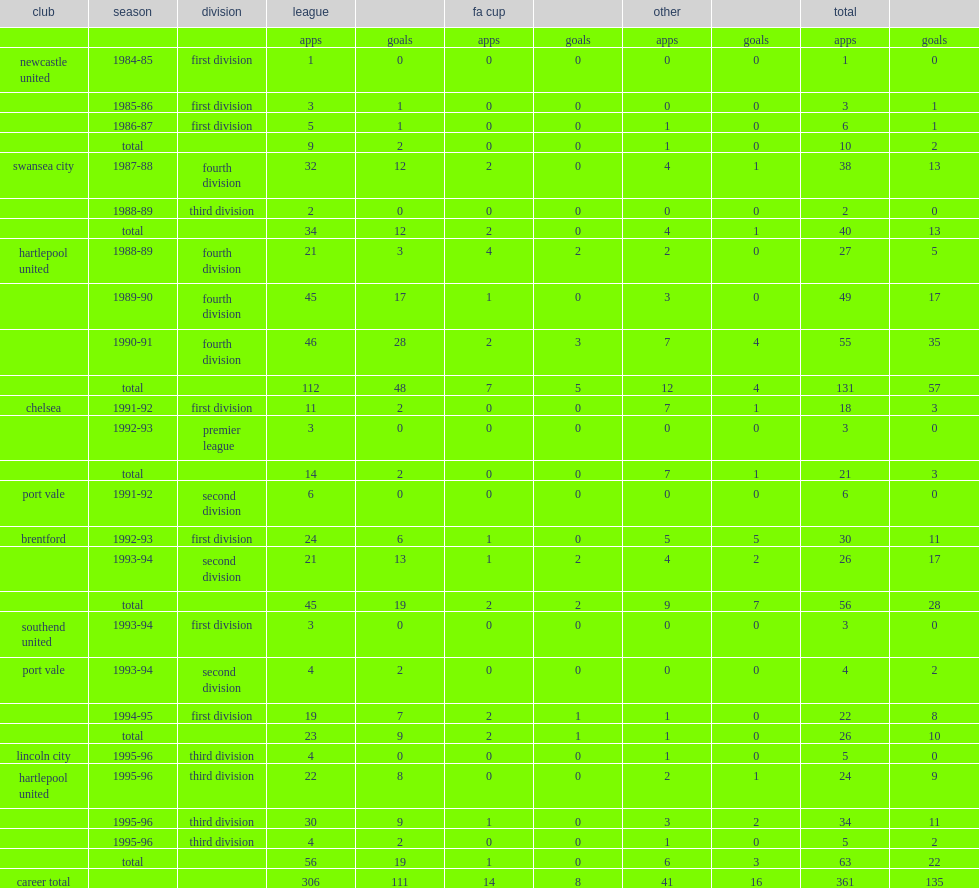How many games did joe allon play with 135 goals? 361.0. 